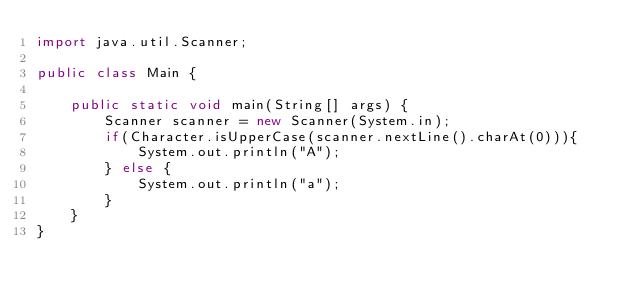Convert code to text. <code><loc_0><loc_0><loc_500><loc_500><_Java_>import java.util.Scanner;

public class Main {

    public static void main(String[] args) {
        Scanner scanner = new Scanner(System.in);
        if(Character.isUpperCase(scanner.nextLine().charAt(0))){
            System.out.println("A");
        } else {
            System.out.println("a");
        }
    }
}</code> 